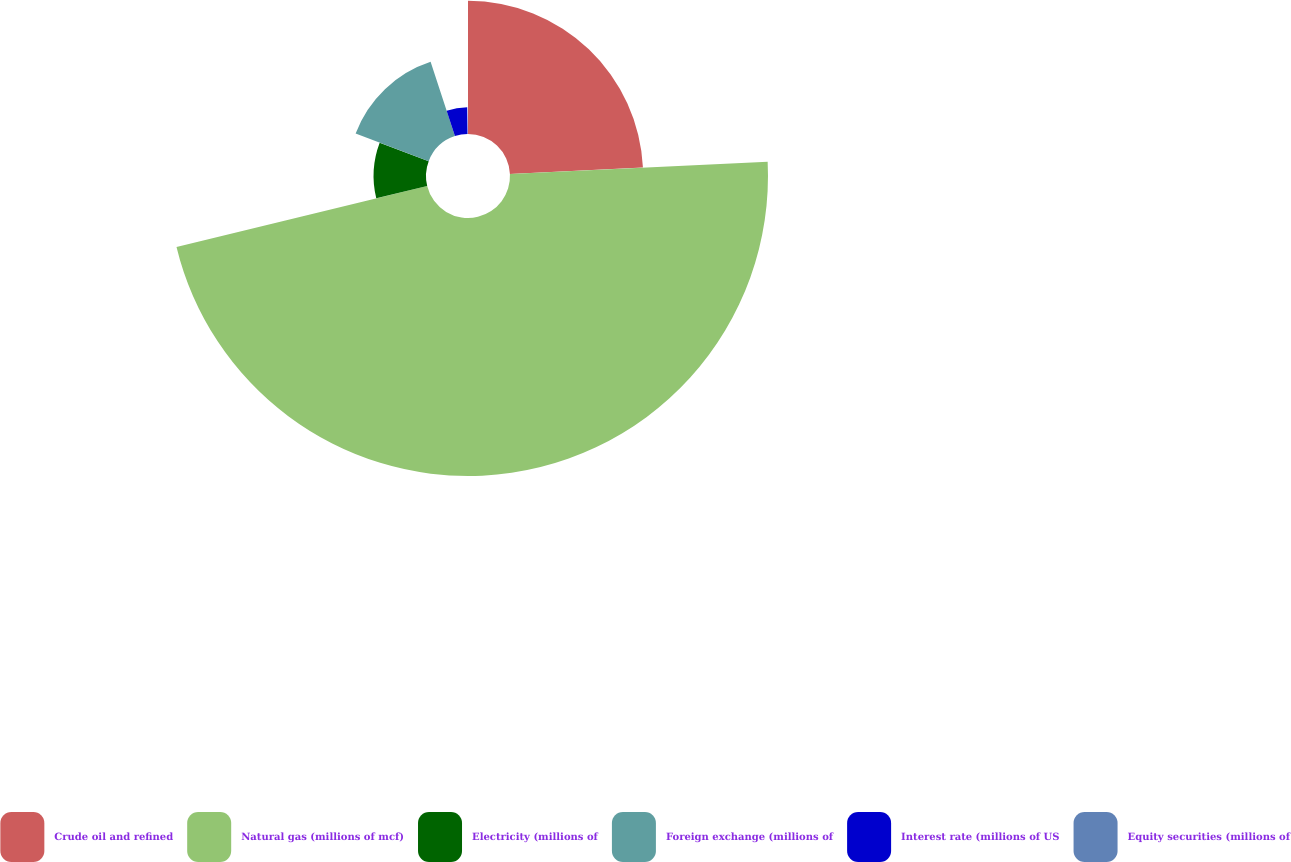Convert chart to OTSL. <chart><loc_0><loc_0><loc_500><loc_500><pie_chart><fcel>Crude oil and refined<fcel>Natural gas (millions of mcf)<fcel>Electricity (millions of<fcel>Foreign exchange (millions of<fcel>Interest rate (millions of US<fcel>Equity securities (millions of<nl><fcel>24.24%<fcel>46.97%<fcel>9.54%<fcel>14.22%<fcel>4.86%<fcel>0.18%<nl></chart> 